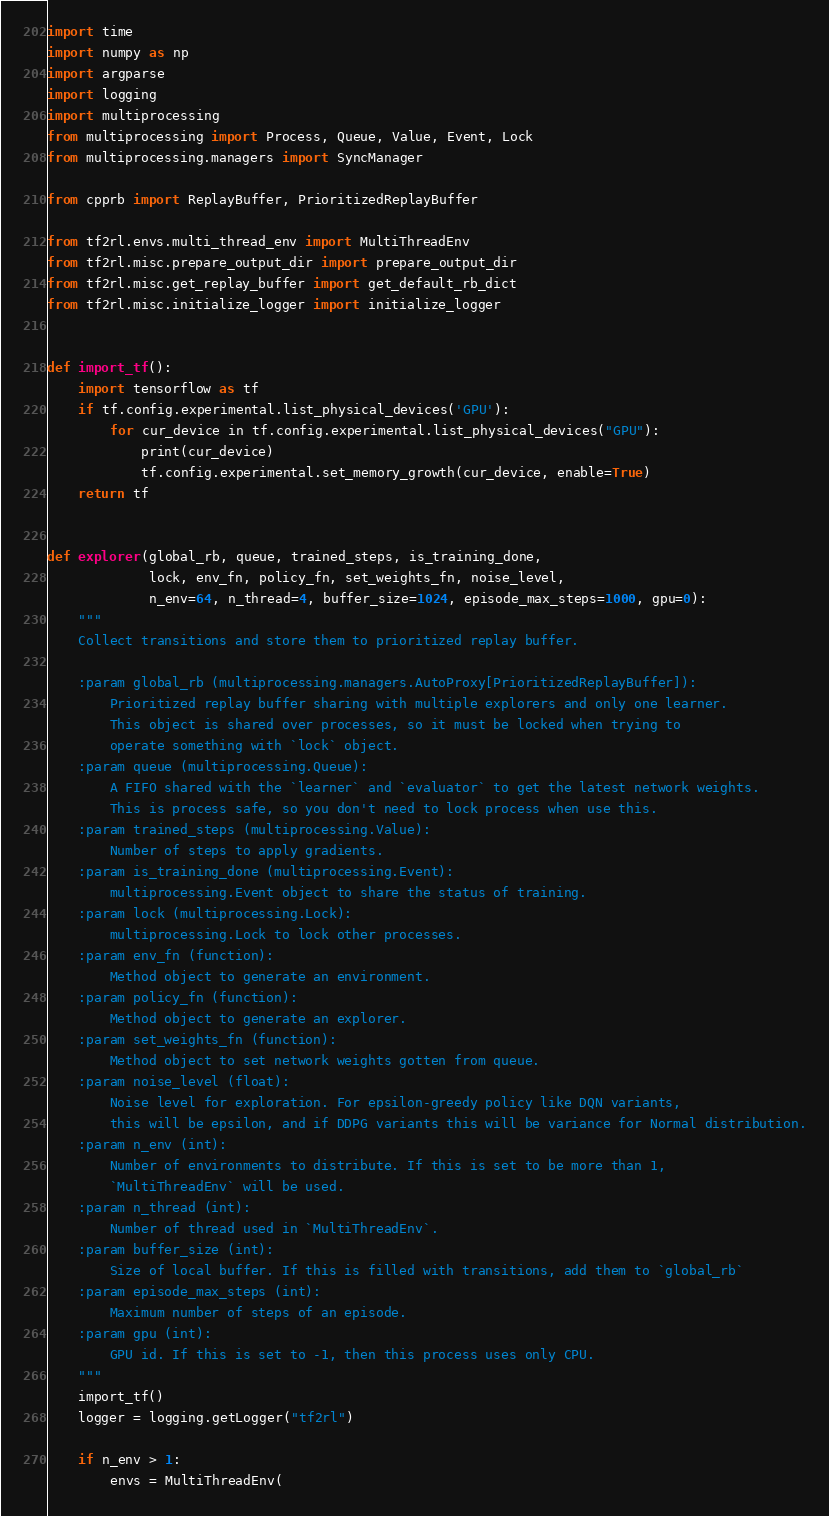Convert code to text. <code><loc_0><loc_0><loc_500><loc_500><_Python_>import time
import numpy as np
import argparse
import logging
import multiprocessing
from multiprocessing import Process, Queue, Value, Event, Lock
from multiprocessing.managers import SyncManager

from cpprb import ReplayBuffer, PrioritizedReplayBuffer

from tf2rl.envs.multi_thread_env import MultiThreadEnv
from tf2rl.misc.prepare_output_dir import prepare_output_dir
from tf2rl.misc.get_replay_buffer import get_default_rb_dict
from tf2rl.misc.initialize_logger import initialize_logger


def import_tf():
    import tensorflow as tf
    if tf.config.experimental.list_physical_devices('GPU'):
        for cur_device in tf.config.experimental.list_physical_devices("GPU"):
            print(cur_device)
            tf.config.experimental.set_memory_growth(cur_device, enable=True)
    return tf


def explorer(global_rb, queue, trained_steps, is_training_done,
             lock, env_fn, policy_fn, set_weights_fn, noise_level,
             n_env=64, n_thread=4, buffer_size=1024, episode_max_steps=1000, gpu=0):
    """
    Collect transitions and store them to prioritized replay buffer.

    :param global_rb (multiprocessing.managers.AutoProxy[PrioritizedReplayBuffer]):
        Prioritized replay buffer sharing with multiple explorers and only one learner.
        This object is shared over processes, so it must be locked when trying to
        operate something with `lock` object.
    :param queue (multiprocessing.Queue):
        A FIFO shared with the `learner` and `evaluator` to get the latest network weights.
        This is process safe, so you don't need to lock process when use this.
    :param trained_steps (multiprocessing.Value):
        Number of steps to apply gradients.
    :param is_training_done (multiprocessing.Event):
        multiprocessing.Event object to share the status of training.
    :param lock (multiprocessing.Lock):
        multiprocessing.Lock to lock other processes.
    :param env_fn (function):
        Method object to generate an environment.
    :param policy_fn (function):
        Method object to generate an explorer.
    :param set_weights_fn (function):
        Method object to set network weights gotten from queue.
    :param noise_level (float):
        Noise level for exploration. For epsilon-greedy policy like DQN variants,
        this will be epsilon, and if DDPG variants this will be variance for Normal distribution.
    :param n_env (int):
        Number of environments to distribute. If this is set to be more than 1,
        `MultiThreadEnv` will be used.
    :param n_thread (int):
        Number of thread used in `MultiThreadEnv`.
    :param buffer_size (int):
        Size of local buffer. If this is filled with transitions, add them to `global_rb`
    :param episode_max_steps (int):
        Maximum number of steps of an episode.
    :param gpu (int):
        GPU id. If this is set to -1, then this process uses only CPU.
    """
    import_tf()
    logger = logging.getLogger("tf2rl")

    if n_env > 1:
        envs = MultiThreadEnv(</code> 